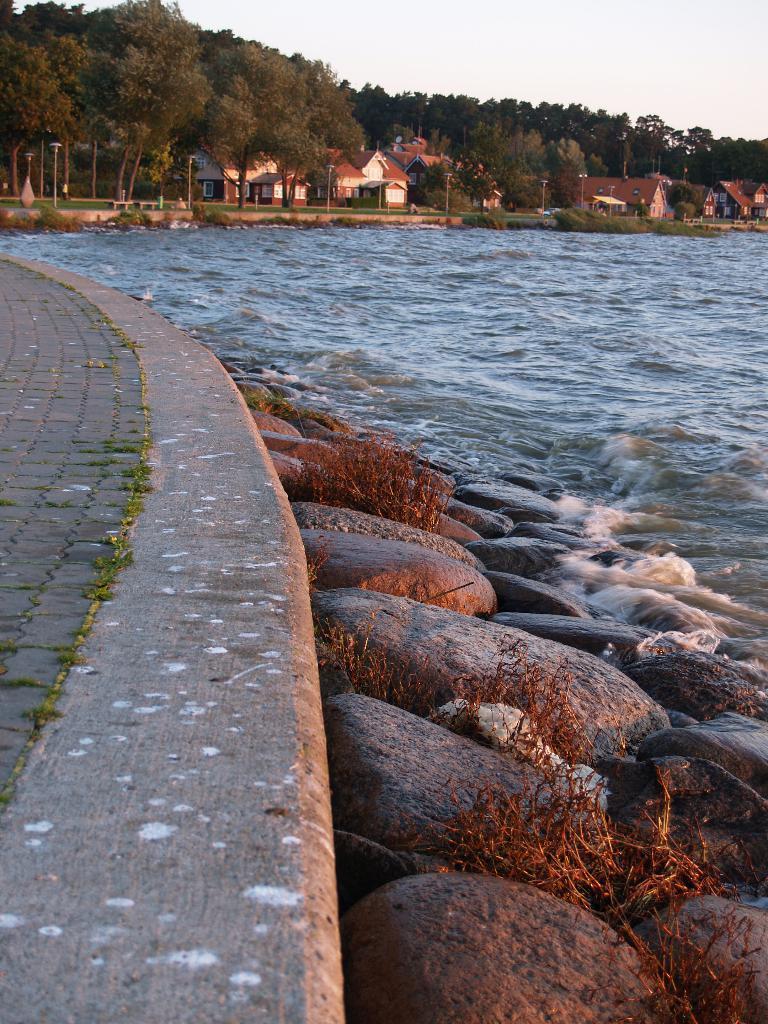How would you summarize this image in a sentence or two? In the image there is a path on the left side with beach on the right side and in the back there are homes with trees in front of them and above its sky. 